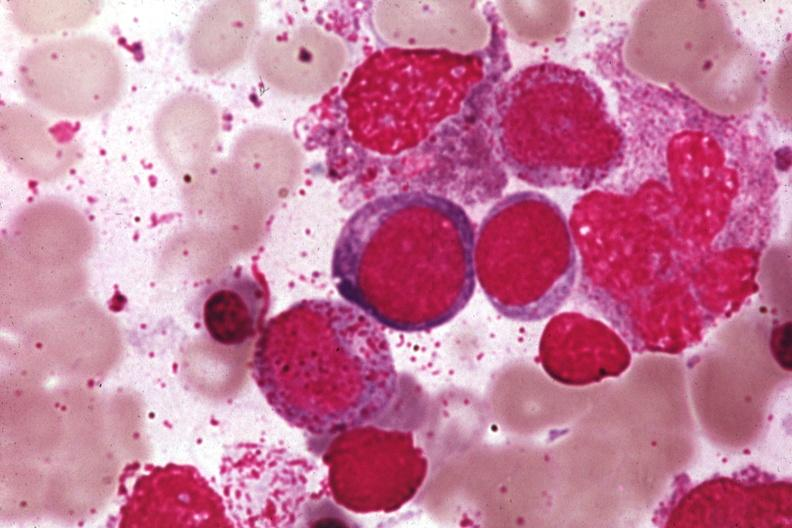s nodular tumor present?
Answer the question using a single word or phrase. No 